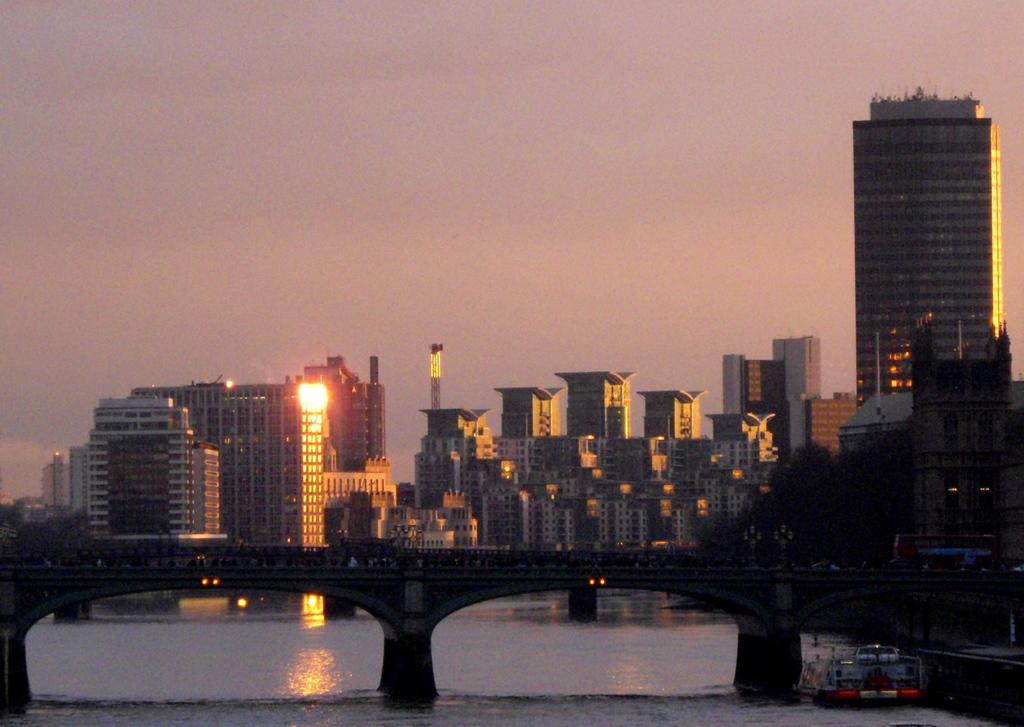What type of view is depicted in the image? The image shows a view of the city. What structure can be seen in the image? There is a concrete and metal bridge in the image. What type of buildings are visible in the background of the image? There are many glass buildings in the background of the image. What is visible in the sky in the image? The sky is clear and visible in the image. Can you tell me how many pears are on the kettle in the image? There are no pears or kettles present in the image; it features a view of the city with a bridge and glass buildings. 